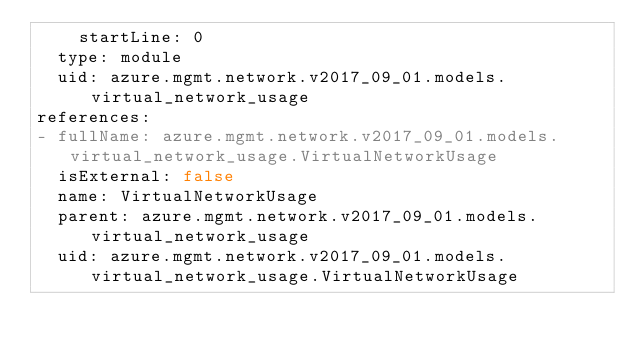Convert code to text. <code><loc_0><loc_0><loc_500><loc_500><_YAML_>    startLine: 0
  type: module
  uid: azure.mgmt.network.v2017_09_01.models.virtual_network_usage
references:
- fullName: azure.mgmt.network.v2017_09_01.models.virtual_network_usage.VirtualNetworkUsage
  isExternal: false
  name: VirtualNetworkUsage
  parent: azure.mgmt.network.v2017_09_01.models.virtual_network_usage
  uid: azure.mgmt.network.v2017_09_01.models.virtual_network_usage.VirtualNetworkUsage
</code> 